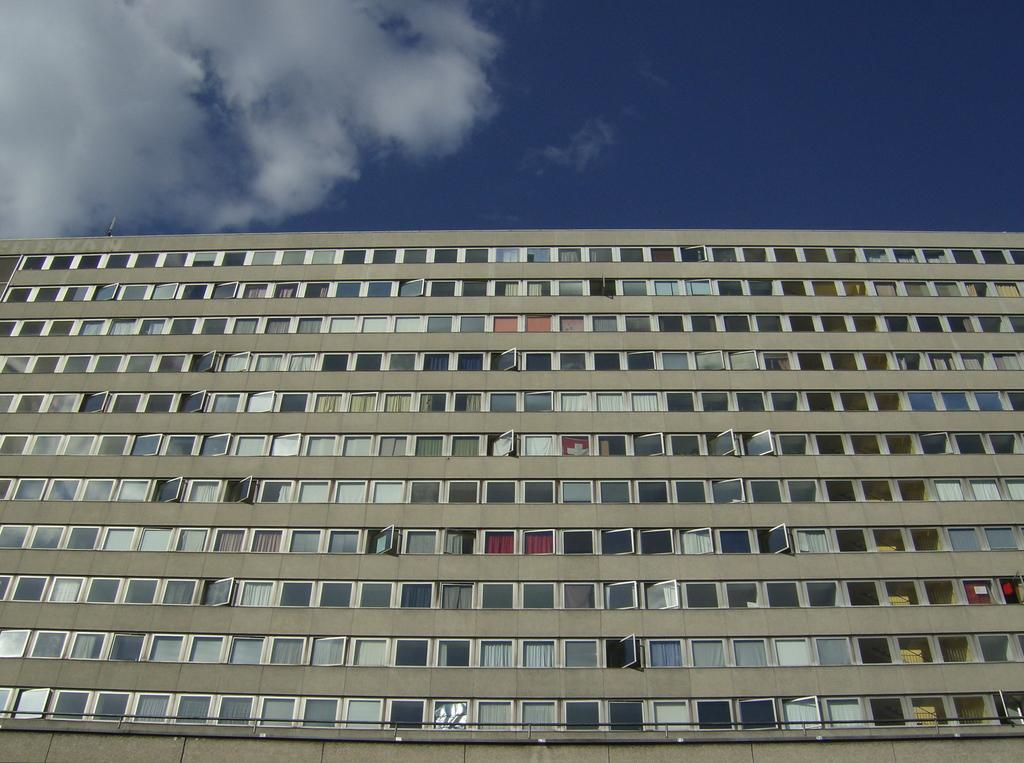What type of structure is present in the image? There is a building in the image. What feature can be seen on the building? The building has windows. Are there any window treatments visible in the image? Yes, there are curtains near the windows. What is visible at the top of the image? The sky is visible at the top of the image. How many pigs can be seen swimming in the stream near the building in the image? There are no pigs or streams present in the image; it only features a building with windows and curtains. 